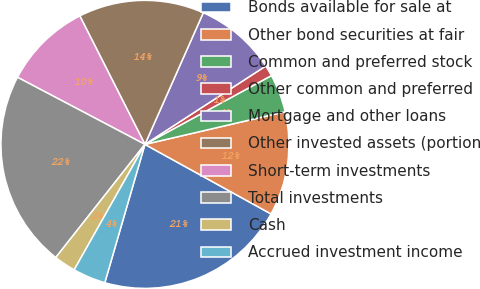Convert chart to OTSL. <chart><loc_0><loc_0><loc_500><loc_500><pie_chart><fcel>Bonds available for sale at<fcel>Other bond securities at fair<fcel>Common and preferred stock<fcel>Other common and preferred<fcel>Mortgage and other loans<fcel>Other invested assets (portion<fcel>Short-term investments<fcel>Total investments<fcel>Cash<fcel>Accrued investment income<nl><fcel>21.47%<fcel>11.66%<fcel>4.29%<fcel>1.23%<fcel>9.2%<fcel>14.11%<fcel>9.82%<fcel>22.09%<fcel>2.45%<fcel>3.68%<nl></chart> 